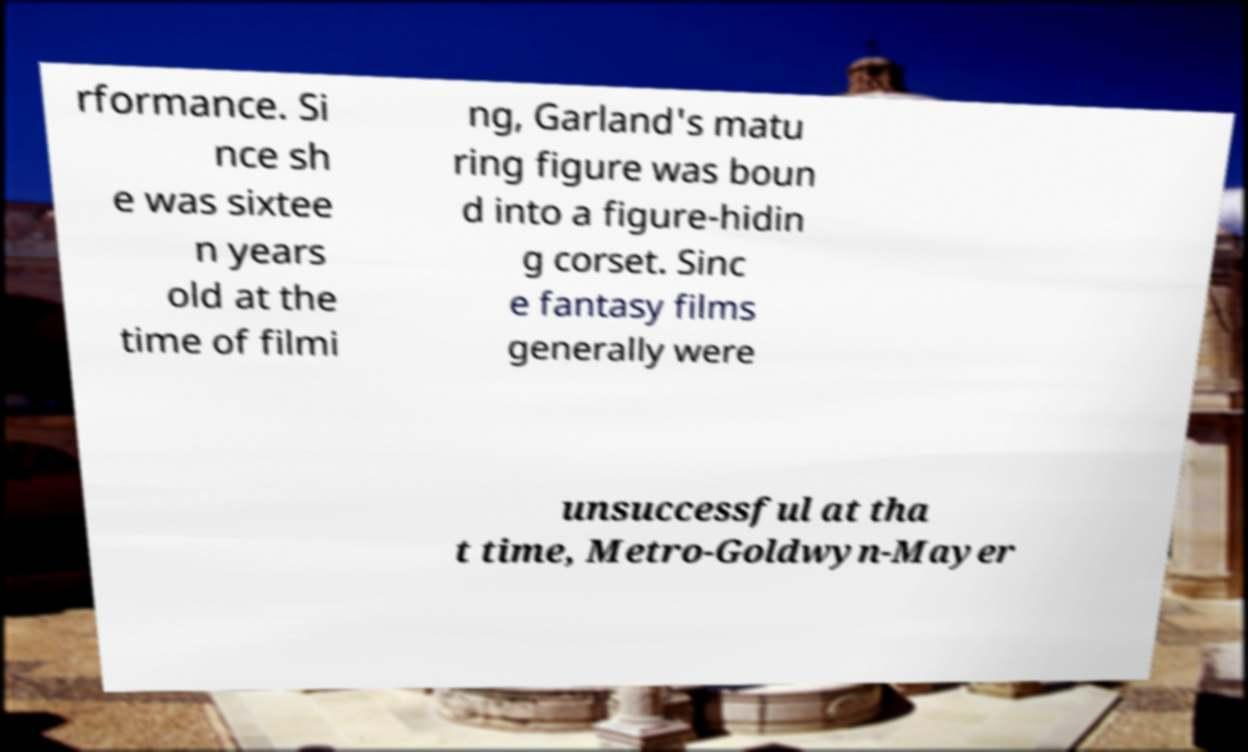For documentation purposes, I need the text within this image transcribed. Could you provide that? rformance. Si nce sh e was sixtee n years old at the time of filmi ng, Garland's matu ring figure was boun d into a figure-hidin g corset. Sinc e fantasy films generally were unsuccessful at tha t time, Metro-Goldwyn-Mayer 